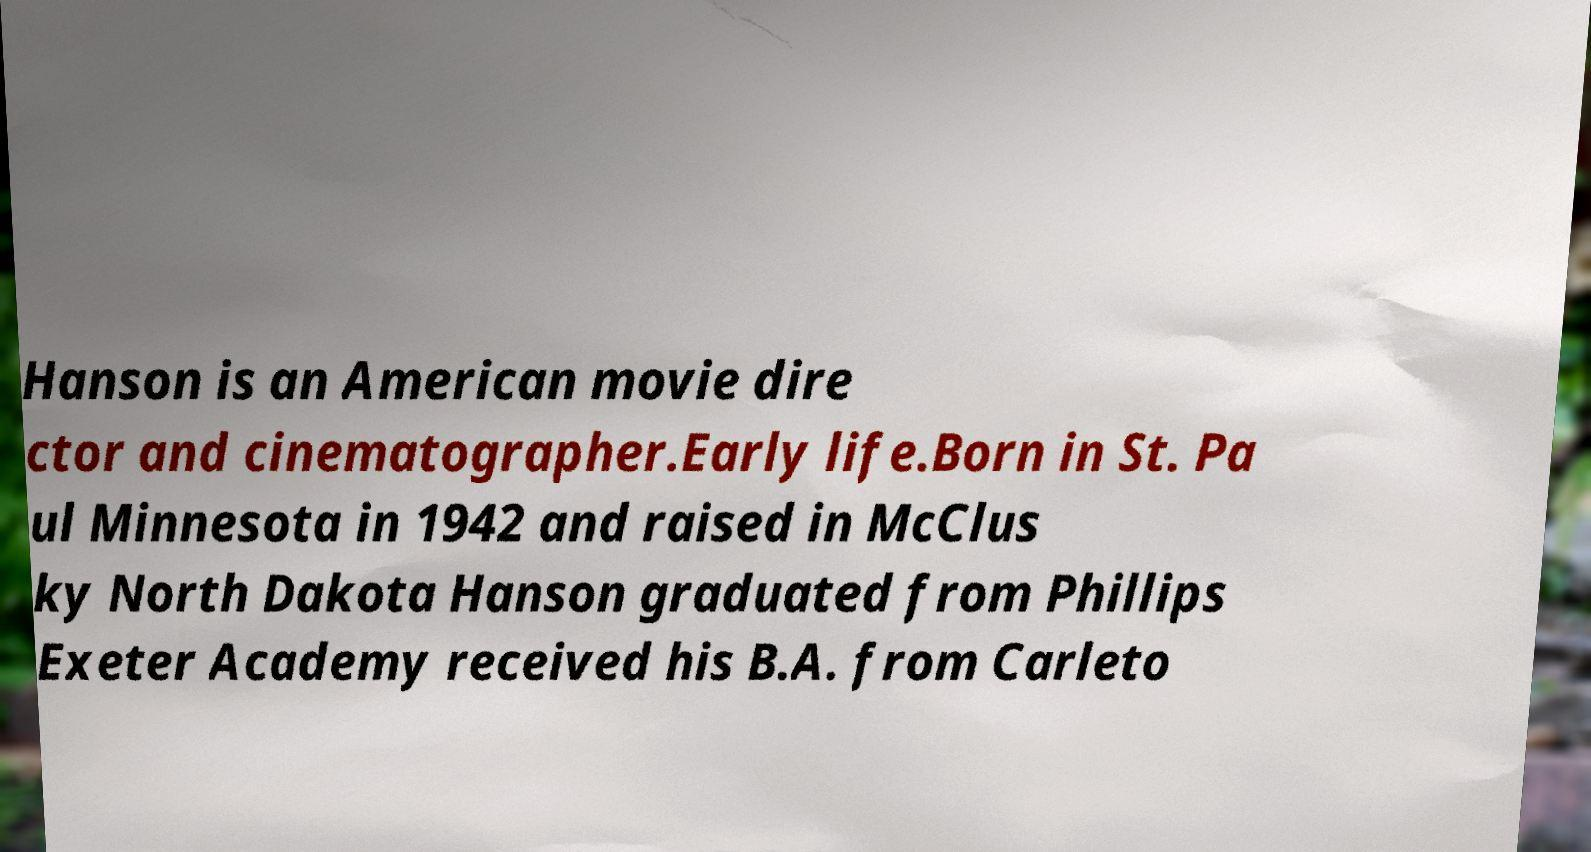Please identify and transcribe the text found in this image. Hanson is an American movie dire ctor and cinematographer.Early life.Born in St. Pa ul Minnesota in 1942 and raised in McClus ky North Dakota Hanson graduated from Phillips Exeter Academy received his B.A. from Carleto 